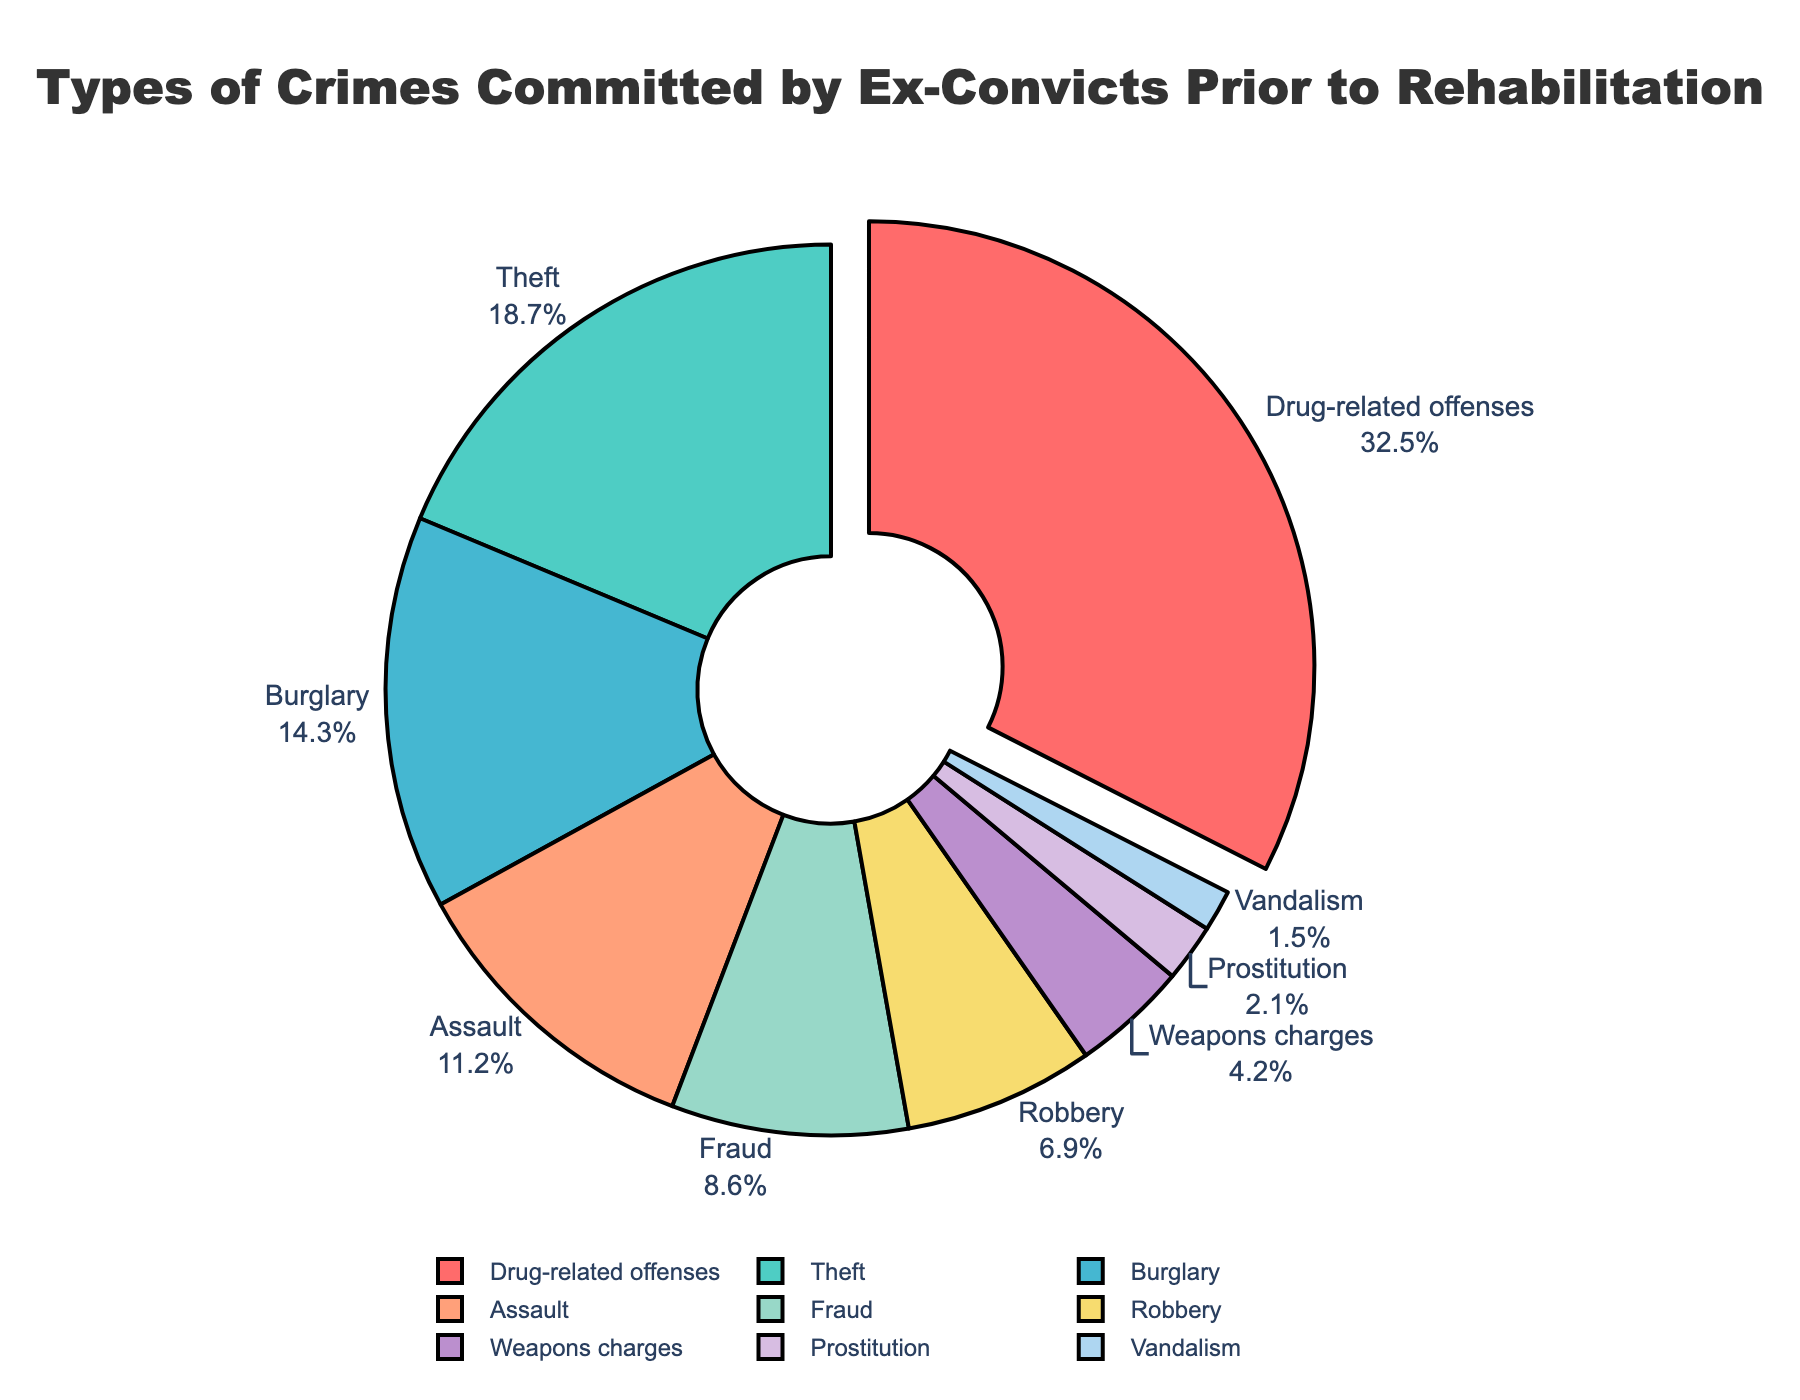Which type of crime is the most common among ex-convicts prior to rehabilitation? Looking at the pie chart, the largest segment is labeled as "Drug-related offenses," with a percentage of 32.5%.
Answer: Drug-related offenses What is the combined percentage of ex-convicts who committed burglary and theft prior to rehabilitation? The percentage for Burglary is 14.3% and for Theft is 18.7%. Adding these together, 14.3% + 18.7% = 33%.
Answer: 33% Which crime type is represented by the smallest segment on the chart? The smallest segment is labeled "Vandalism," with a percentage of 1.5%.
Answer: Vandalism How does the percentage of ex-convicts with assault charges compare to those with fraud charges? The chart shows that Assault has a percentage of 11.2%, while Fraud has 8.6%. Therefore, Assault is higher by 11.2% - 8.6% = 2.6%.
Answer: Assault is higher by 2.6% What percentage of ex-convicts committed robbery compared to those with weapons charges? The percentage for Robbery is 6.9% and for Weapons charges is 4.2%. Therefore, Robbery is higher by 6.9% - 4.2% = 2.7%.
Answer: Robbery is higher by 2.7% Which segments are pulled out from the center of the pie chart, indicating emphasis? The only segment pulled out from the center is "Drug-related offenses," marked in red.
Answer: Drug-related offenses What is the total percentage of ex-convicts who committed drug-related offenses, theft, and assault? Adding the percentages for Drug-related offenses (32.5%), Theft (18.7%), and Assault (11.2%) together, 32.5% + 18.7% + 11.2% = 62.4%.
Answer: 62.4% Which color represents the segment for burglary, and what is its percentage? The segment for Burglary is colored in blue and has a percentage of 14.3%.
Answer: Blue, 14.3% Is the percentage of ex-convicts who committed fraud greater or less than 10%? The percentage of ex-convicts who committed Fraud is 8.6%, which is less than 10%.
Answer: Less than 10% 